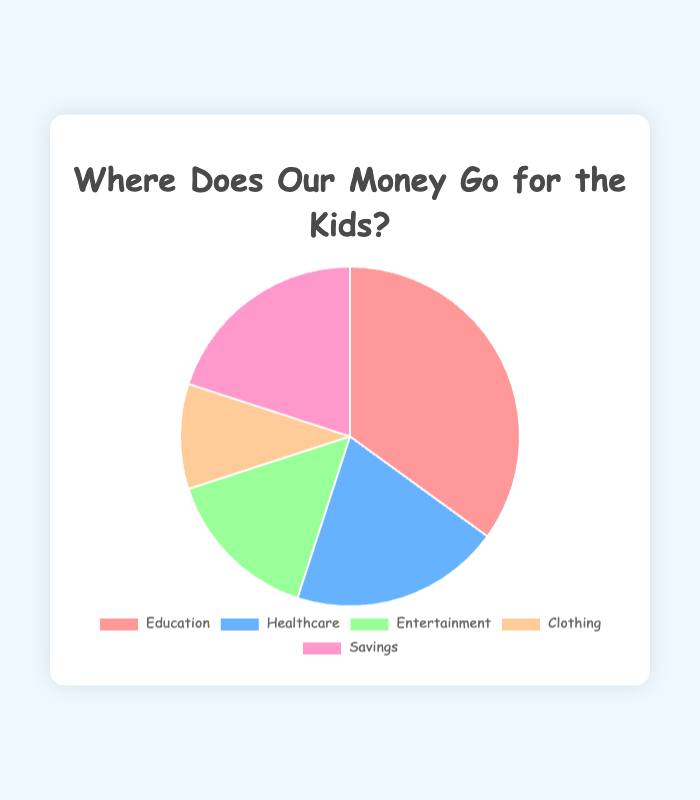What's the largest portion of the household budget allocation for kids' needs? The largest portion is identified as the segment with the highest percentage. From the pie chart, 'Education' has the largest share at 35%.
Answer: Education How much more is spent on Education compared to Entertainment? To find the difference, subtract the percentage of Entertainment from Education: 35% (Education) - 15% (Entertainment) = 20%.
Answer: 20% Which two needs have the same percentage allocation? By checking the segments, 'Healthcare' and 'Savings' both have 20% each.
Answer: Healthcare and Savings What percentage of the household budget is allocated to non-educational needs? Non-educational needs include Healthcare, Entertainment, Clothing, and Savings. Sum these percentages: 20% + 15% + 10% + 20% = 65%.
Answer: 65% What is the combined budget allocation for Entertainment and Clothing? Add the percentages for Entertainment and Clothing: 15% (Entertainment) + 10% (Clothing) = 25%.
Answer: 25% Which category is the smallest portion of the budget? The smallest segment in the chart is 'Clothing' with 10%.
Answer: Clothing By how much does the allocation for Healthcare exceed that for Clothing? Subtract the percentage for Clothing from that for Healthcare: 20% (Healthcare) - 10% (Clothing) = 10%.
Answer: 10% Which colors represent Education and Entertainment, respectively? Identify the colors on the chart: Education is represented by the first color segment, which is light red, and Entertainment is represented by light green.
Answer: Light red (Education) and light green (Entertainment) Is the percentage allocated to Savings equal to or greater than that for Entertainment? Compare the two percentages: Savings (20%) is greater than Entertainment (15%).
Answer: Greater What is the average allocation percentage across all five categories? Sum all the percentages and divide by the number of categories: (35% + 20% + 15% + 10% + 20%) / 5 = 20%.
Answer: 20% 